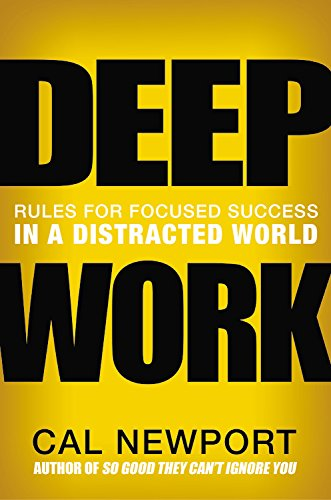Is this book related to Business & Money? Yes, 'Deep Work' is directly related to the Business & Money category, as it offers actionable advice on how to achieve focused success in professional settings. 